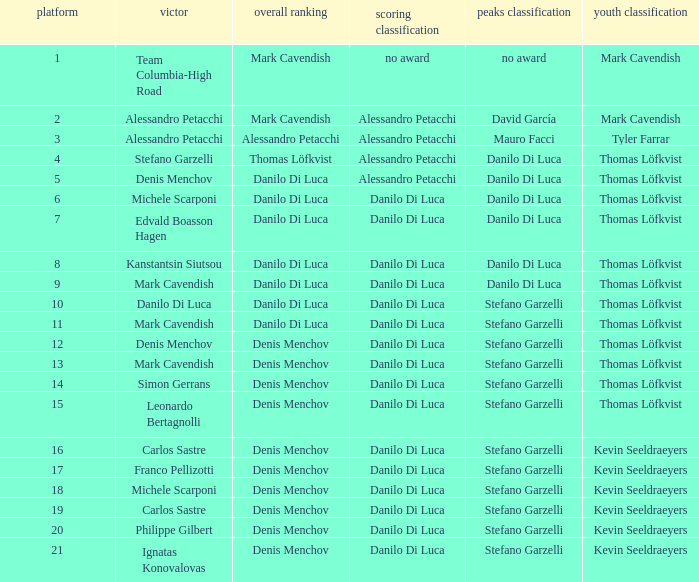When danilo di luca is the champion, who is the general classification? Danilo Di Luca. 